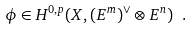Convert formula to latex. <formula><loc_0><loc_0><loc_500><loc_500>\phi \in H ^ { 0 , p } ( X , ( E ^ { m } ) ^ { \vee } \otimes E ^ { n } ) \ .</formula> 